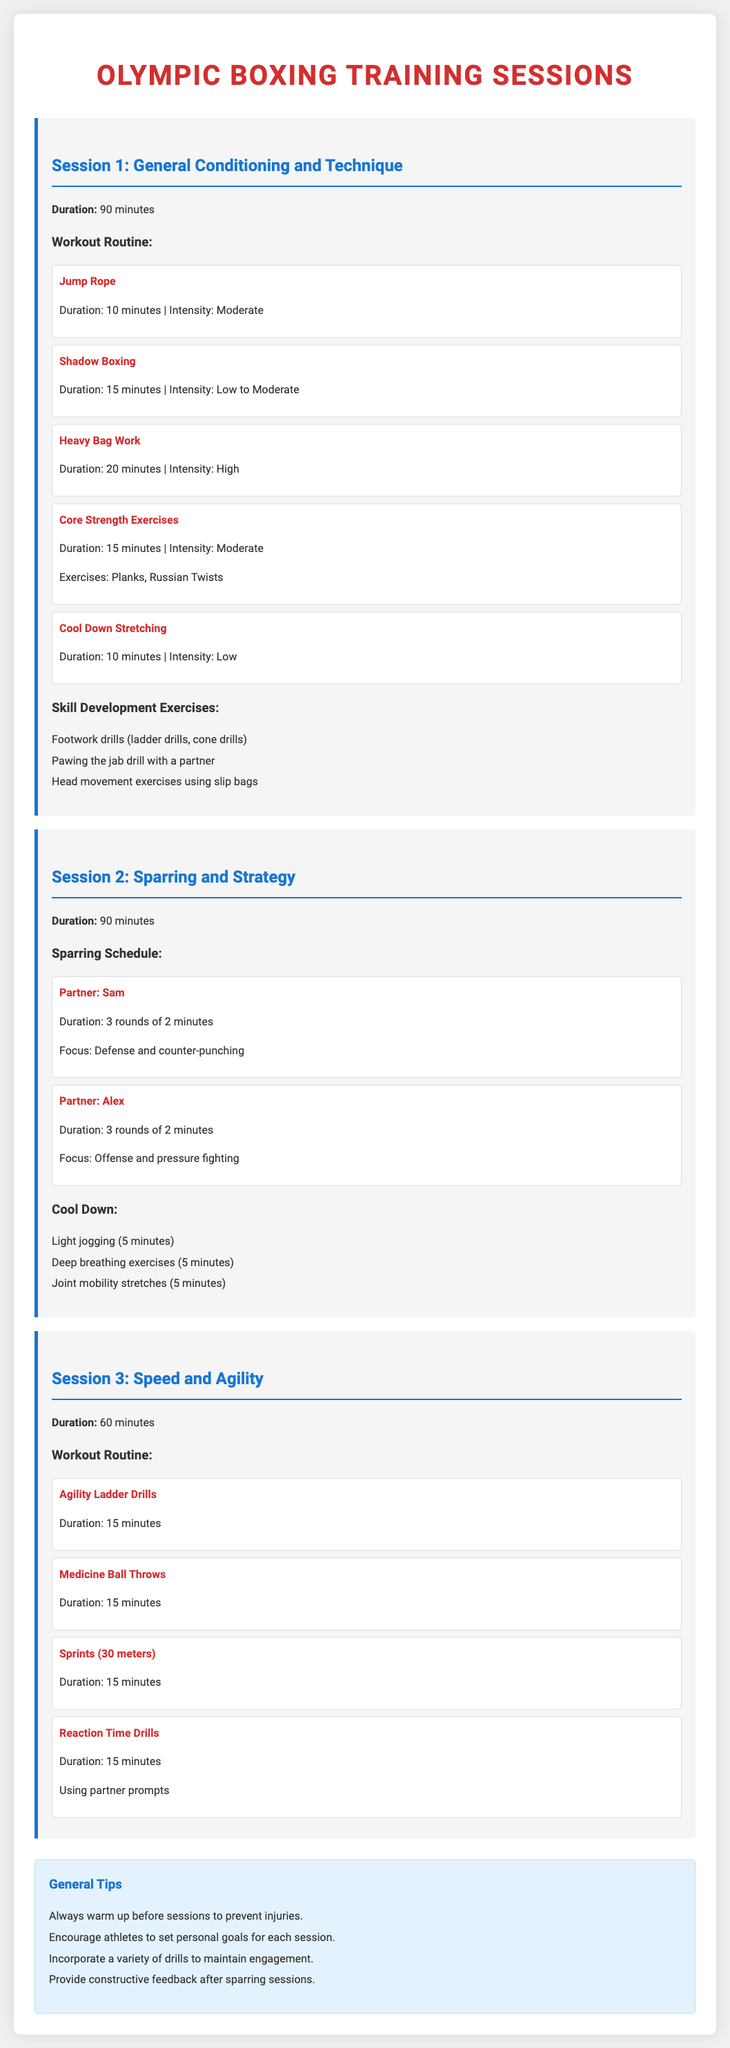What is the duration of Session 1? The duration is listed at the beginning of Session 1 as 90 minutes.
Answer: 90 minutes What are the two movements included in the Core Strength Exercises? The Core Strength Exercises detail two specific movements: Planks and Russian Twists.
Answer: Planks, Russian Twists What is the focus during the sparring with Sam? The focus on Sam's sparring is described as Defense and counter-punching.
Answer: Defense and counter-punching What is the total duration for the Speed and Agility session? The total duration for the Speed and Agility session is specified as 60 minutes.
Answer: 60 minutes How many rounds are scheduled for sparring with Alex? The rounds for sparring with Alex are detailed as 3 rounds of 2 minutes each.
Answer: 3 rounds of 2 minutes Which exercise follows Heavy Bag Work in Session 1? Following Heavy Bag Work, the next exercise listed is Core Strength Exercises.
Answer: Core Strength Exercises What type of drills are mentioned for footwork development? Footwork drills are described as ladder drills and cone drills.
Answer: ladder drills, cone drills What is a suggested activity for the cool-down period after sparring? A suggested activity for cool-down is light jogging listed for 5 minutes.
Answer: Light jogging What is included in the General Tips section? The General Tips section includes advice on warming up, setting personal goals, and providing feedback.
Answer: warm up, set personal goals, provide feedback 